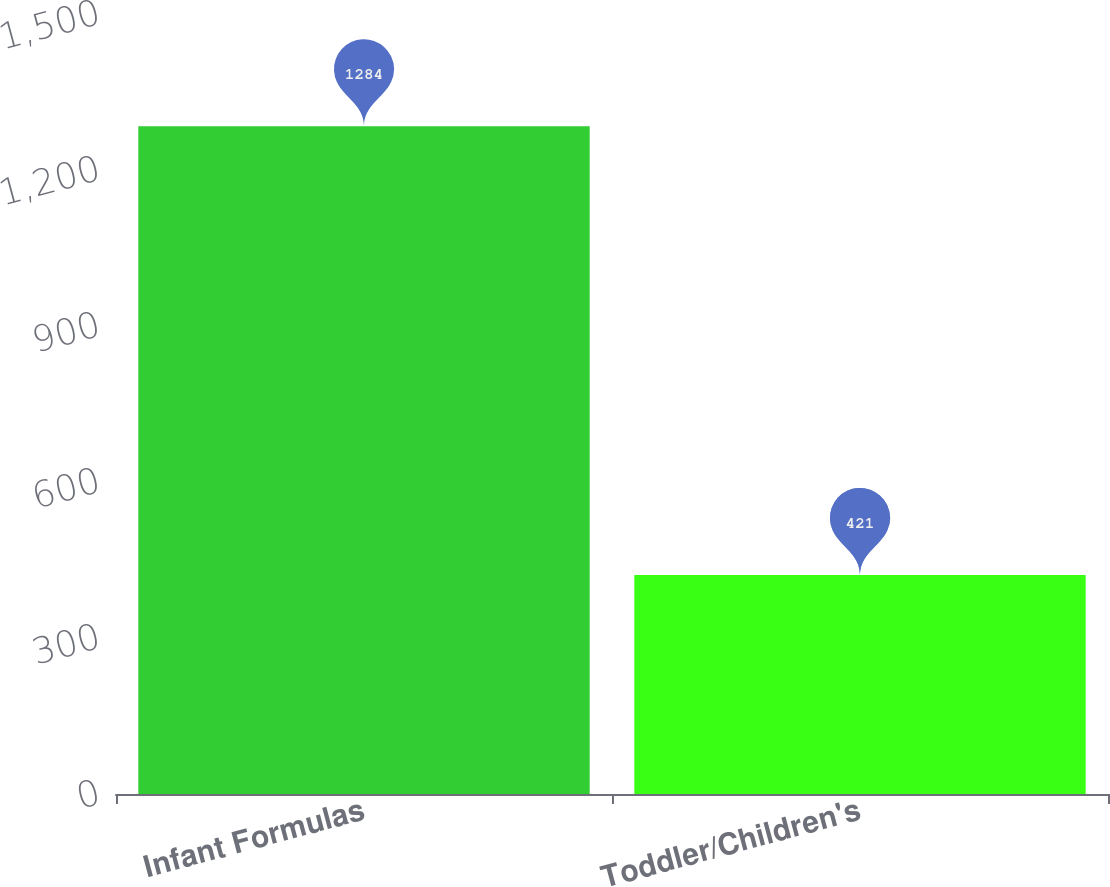Convert chart. <chart><loc_0><loc_0><loc_500><loc_500><bar_chart><fcel>Infant Formulas<fcel>Toddler/Children's<nl><fcel>1284<fcel>421<nl></chart> 